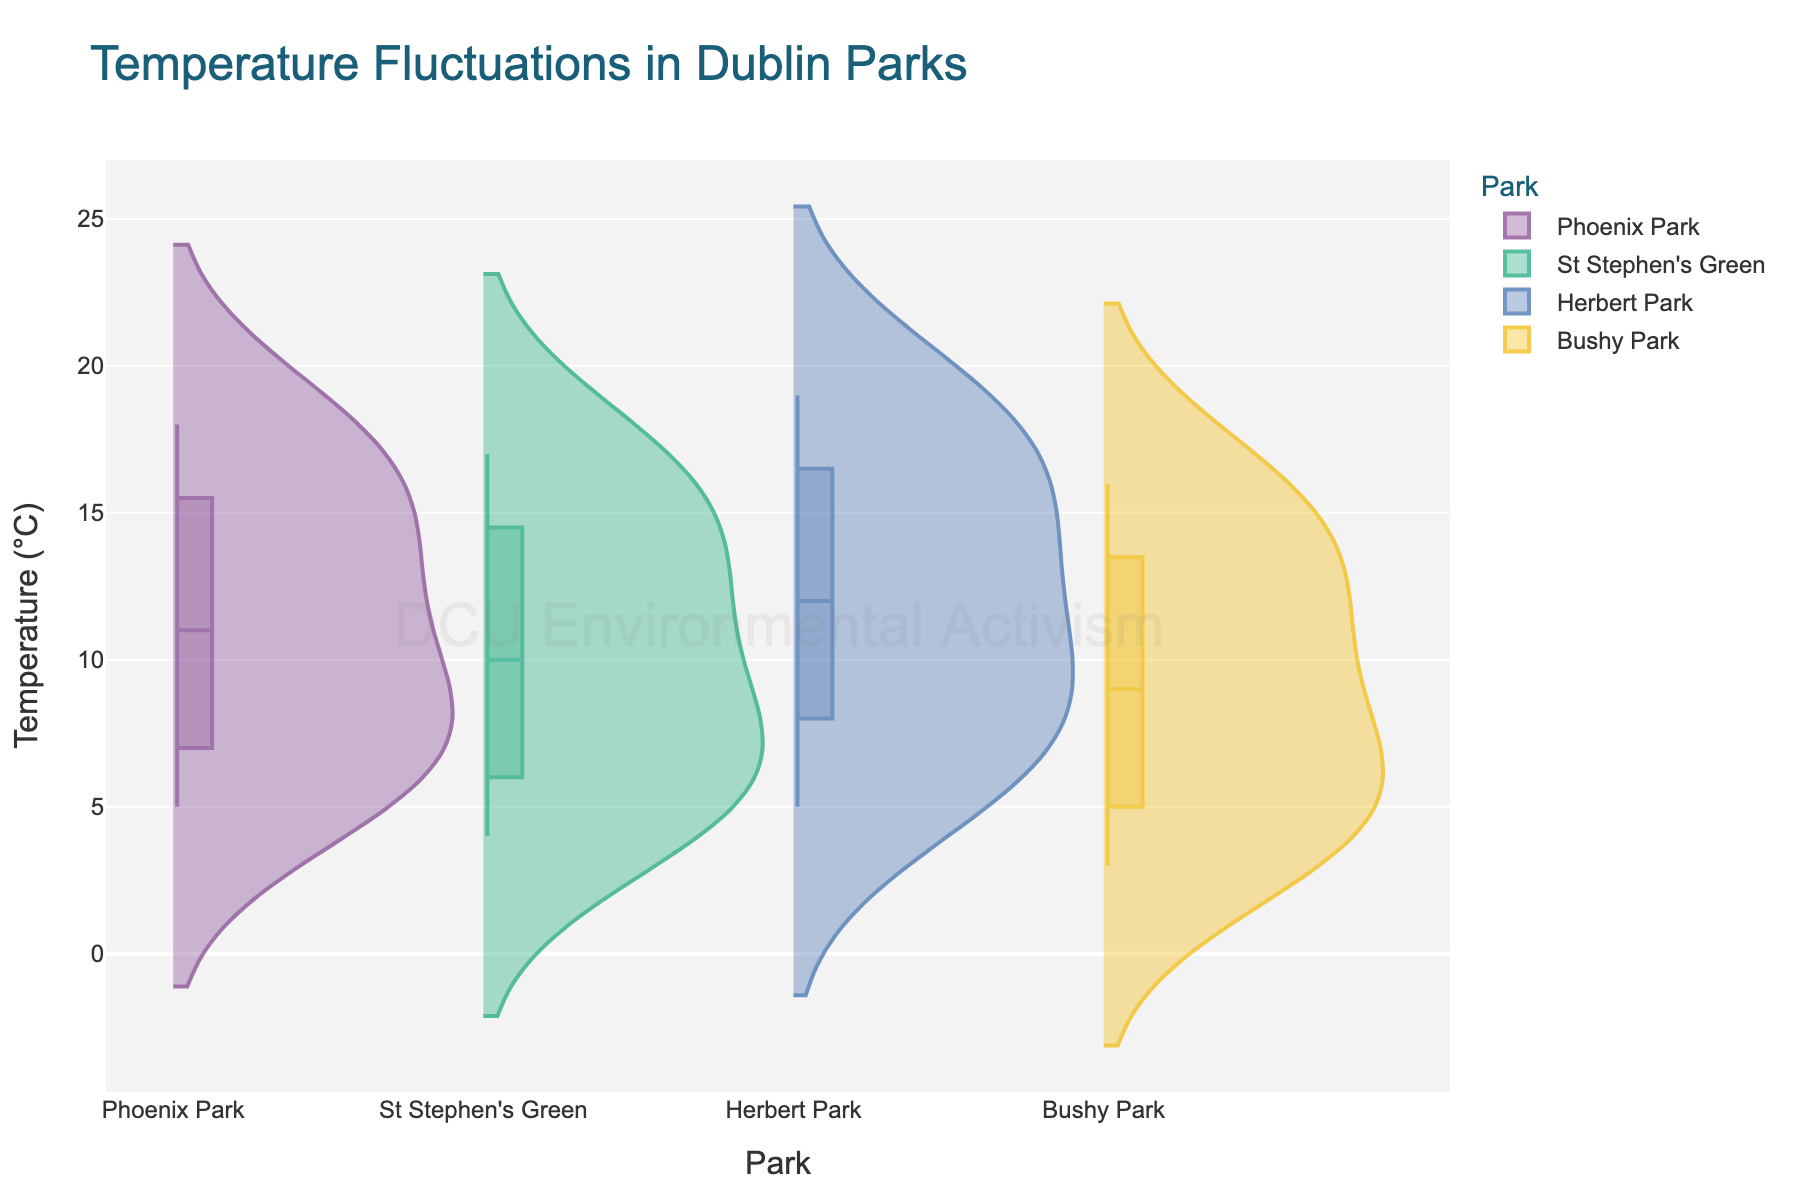What's the title of the chart? The title is usually positioned at the top center of the chart and provides an overview of what the chart represents.
Answer: Temperature Fluctuations in Dublin Parks Which park shows the highest median temperature in July? The median temperature is indicated by the line in the box within each violin plot. Compare the median lines for July across all parks.
Answer: Herbert Park How do the temperatures in Phoenix Park and St Stephen's Green compare in March? Look at the March data for both Phoenix Park and St Stephen's Green. Identify their points within the violin plots and compare their positions on the y-axis.
Answer: Phoenix Park: 8°C, St Stephen's Green: 7°C What is the range of temperatures observed in Bushy Park across the year? The range is the difference between the highest and lowest data points in a park's distribution. Observe the top and bottom of the violin plot for Bushy Park.
Answer: 16°C - 3°C = 13°C Which month shows the lowest temperature in all parks combined? Identify the lowest individual temperatures within each month across all parks and determine the overall lowest temperature.
Answer: January and December Are there any parks where the temperature does not go below 5°C? Look at the lower parts of each park's violin plot to see if any park's lowest data point is at or above 5°C.
Answer: Herbert Park What is the interquartile range (IQR) of temperatures in Herbert Park in August? The IQR is the range between the first quartile (25th percentile) and third quartile (75th percentile). Observe the box within the August section for Herbert Park.
Answer: Not directly answerable as exact quartiles are not provided Between Phoenix Park and Bushy Park, which park experiences a greater fluctuation in temperature? Greater fluctuation is indicated by a taller and more spread-out violin plot. Compare the overall height and spread from top to bottom for both parks over the year.
Answer: Bushy Park Which park has the most consistent temperature through the year? Consistency is shown by a tighter and less spread-out violin plot. Find the park with the narrowest and least varied distribution.
Answer: St Stephen's Green What temperatures are considered outliers in St Stephen's Green? Outliers are marked as individual points outside the range of the main distribution. Look for isolated points beyond the general spread of the violin plot for St Stephen's Green.
Answer: No specific outliers marked within given data 